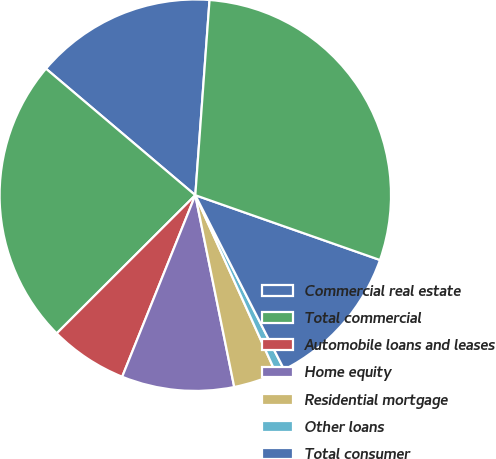Convert chart to OTSL. <chart><loc_0><loc_0><loc_500><loc_500><pie_chart><fcel>Commercial real estate<fcel>Total commercial<fcel>Automobile loans and leases<fcel>Home equity<fcel>Residential mortgage<fcel>Other loans<fcel>Total consumer<fcel>Total allowance for loan and<nl><fcel>14.97%<fcel>23.66%<fcel>6.43%<fcel>9.28%<fcel>3.58%<fcel>0.73%<fcel>12.13%<fcel>29.21%<nl></chart> 